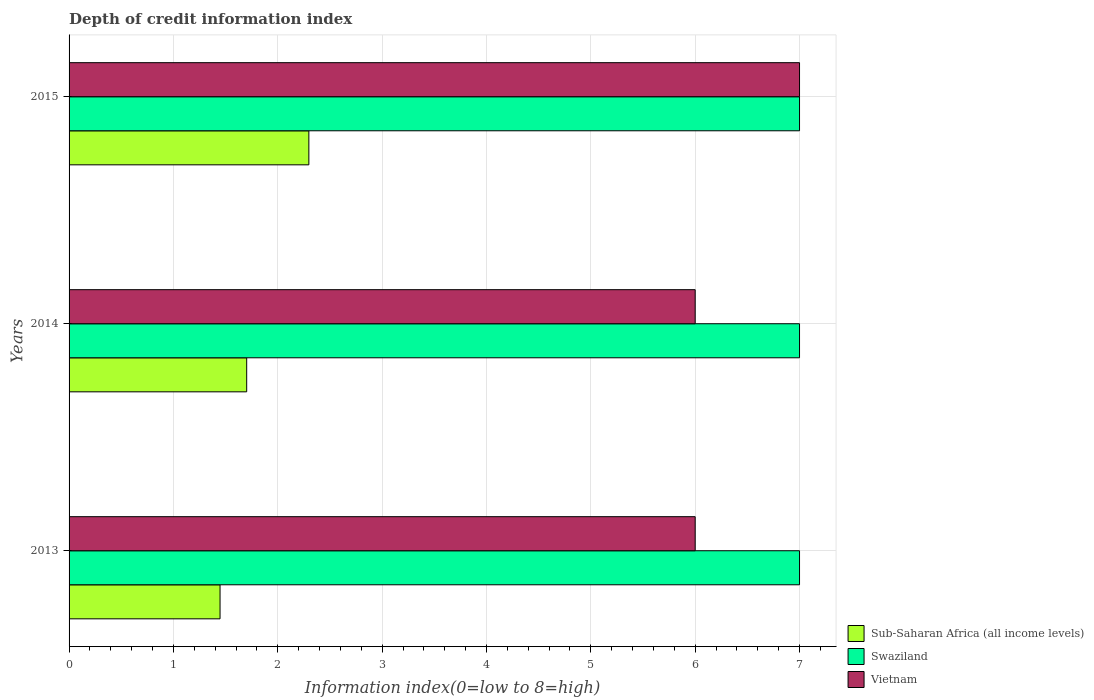How many bars are there on the 1st tick from the top?
Give a very brief answer. 3. How many bars are there on the 2nd tick from the bottom?
Your response must be concise. 3. What is the label of the 3rd group of bars from the top?
Your answer should be very brief. 2013. In how many cases, is the number of bars for a given year not equal to the number of legend labels?
Offer a very short reply. 0. What is the information index in Sub-Saharan Africa (all income levels) in 2013?
Make the answer very short. 1.45. Across all years, what is the maximum information index in Sub-Saharan Africa (all income levels)?
Offer a very short reply. 2.3. In which year was the information index in Swaziland maximum?
Provide a short and direct response. 2013. In which year was the information index in Sub-Saharan Africa (all income levels) minimum?
Provide a succinct answer. 2013. What is the total information index in Sub-Saharan Africa (all income levels) in the graph?
Give a very brief answer. 5.45. What is the difference between the information index in Sub-Saharan Africa (all income levels) in 2014 and that in 2015?
Offer a terse response. -0.6. What is the difference between the information index in Swaziland in 2013 and the information index in Vietnam in 2015?
Make the answer very short. 0. What is the average information index in Vietnam per year?
Your answer should be compact. 6.33. In the year 2014, what is the difference between the information index in Vietnam and information index in Sub-Saharan Africa (all income levels)?
Your answer should be compact. 4.3. In how many years, is the information index in Sub-Saharan Africa (all income levels) greater than 1 ?
Give a very brief answer. 3. What is the ratio of the information index in Swaziland in 2013 to that in 2015?
Provide a succinct answer. 1. Is the information index in Swaziland in 2013 less than that in 2015?
Make the answer very short. No. Is the difference between the information index in Vietnam in 2013 and 2014 greater than the difference between the information index in Sub-Saharan Africa (all income levels) in 2013 and 2014?
Offer a terse response. Yes. What is the difference between the highest and the second highest information index in Vietnam?
Ensure brevity in your answer.  1. What is the difference between the highest and the lowest information index in Sub-Saharan Africa (all income levels)?
Provide a short and direct response. 0.85. Is the sum of the information index in Sub-Saharan Africa (all income levels) in 2013 and 2014 greater than the maximum information index in Swaziland across all years?
Offer a terse response. No. What does the 3rd bar from the top in 2014 represents?
Offer a very short reply. Sub-Saharan Africa (all income levels). What does the 1st bar from the bottom in 2014 represents?
Give a very brief answer. Sub-Saharan Africa (all income levels). How many bars are there?
Your response must be concise. 9. How many years are there in the graph?
Provide a succinct answer. 3. Are the values on the major ticks of X-axis written in scientific E-notation?
Provide a short and direct response. No. Does the graph contain any zero values?
Give a very brief answer. No. Does the graph contain grids?
Provide a short and direct response. Yes. How many legend labels are there?
Offer a terse response. 3. How are the legend labels stacked?
Offer a very short reply. Vertical. What is the title of the graph?
Your answer should be very brief. Depth of credit information index. What is the label or title of the X-axis?
Keep it short and to the point. Information index(0=low to 8=high). What is the Information index(0=low to 8=high) in Sub-Saharan Africa (all income levels) in 2013?
Keep it short and to the point. 1.45. What is the Information index(0=low to 8=high) of Swaziland in 2013?
Provide a succinct answer. 7. What is the Information index(0=low to 8=high) of Sub-Saharan Africa (all income levels) in 2014?
Provide a short and direct response. 1.7. What is the Information index(0=low to 8=high) of Sub-Saharan Africa (all income levels) in 2015?
Provide a succinct answer. 2.3. What is the Information index(0=low to 8=high) of Swaziland in 2015?
Make the answer very short. 7. Across all years, what is the maximum Information index(0=low to 8=high) in Sub-Saharan Africa (all income levels)?
Make the answer very short. 2.3. Across all years, what is the maximum Information index(0=low to 8=high) of Swaziland?
Keep it short and to the point. 7. Across all years, what is the minimum Information index(0=low to 8=high) in Sub-Saharan Africa (all income levels)?
Give a very brief answer. 1.45. Across all years, what is the minimum Information index(0=low to 8=high) in Swaziland?
Offer a terse response. 7. What is the total Information index(0=low to 8=high) in Sub-Saharan Africa (all income levels) in the graph?
Your answer should be very brief. 5.45. What is the total Information index(0=low to 8=high) of Swaziland in the graph?
Ensure brevity in your answer.  21. What is the difference between the Information index(0=low to 8=high) in Sub-Saharan Africa (all income levels) in 2013 and that in 2014?
Keep it short and to the point. -0.26. What is the difference between the Information index(0=low to 8=high) in Swaziland in 2013 and that in 2014?
Provide a succinct answer. 0. What is the difference between the Information index(0=low to 8=high) of Vietnam in 2013 and that in 2014?
Provide a short and direct response. 0. What is the difference between the Information index(0=low to 8=high) of Sub-Saharan Africa (all income levels) in 2013 and that in 2015?
Provide a short and direct response. -0.85. What is the difference between the Information index(0=low to 8=high) in Sub-Saharan Africa (all income levels) in 2014 and that in 2015?
Give a very brief answer. -0.6. What is the difference between the Information index(0=low to 8=high) in Swaziland in 2014 and that in 2015?
Make the answer very short. 0. What is the difference between the Information index(0=low to 8=high) of Sub-Saharan Africa (all income levels) in 2013 and the Information index(0=low to 8=high) of Swaziland in 2014?
Keep it short and to the point. -5.55. What is the difference between the Information index(0=low to 8=high) in Sub-Saharan Africa (all income levels) in 2013 and the Information index(0=low to 8=high) in Vietnam in 2014?
Provide a succinct answer. -4.55. What is the difference between the Information index(0=low to 8=high) in Sub-Saharan Africa (all income levels) in 2013 and the Information index(0=low to 8=high) in Swaziland in 2015?
Ensure brevity in your answer.  -5.55. What is the difference between the Information index(0=low to 8=high) in Sub-Saharan Africa (all income levels) in 2013 and the Information index(0=low to 8=high) in Vietnam in 2015?
Ensure brevity in your answer.  -5.55. What is the difference between the Information index(0=low to 8=high) in Swaziland in 2013 and the Information index(0=low to 8=high) in Vietnam in 2015?
Offer a very short reply. 0. What is the difference between the Information index(0=low to 8=high) in Sub-Saharan Africa (all income levels) in 2014 and the Information index(0=low to 8=high) in Swaziland in 2015?
Your answer should be compact. -5.3. What is the difference between the Information index(0=low to 8=high) in Sub-Saharan Africa (all income levels) in 2014 and the Information index(0=low to 8=high) in Vietnam in 2015?
Ensure brevity in your answer.  -5.3. What is the average Information index(0=low to 8=high) of Sub-Saharan Africa (all income levels) per year?
Provide a succinct answer. 1.82. What is the average Information index(0=low to 8=high) of Vietnam per year?
Provide a succinct answer. 6.33. In the year 2013, what is the difference between the Information index(0=low to 8=high) in Sub-Saharan Africa (all income levels) and Information index(0=low to 8=high) in Swaziland?
Make the answer very short. -5.55. In the year 2013, what is the difference between the Information index(0=low to 8=high) of Sub-Saharan Africa (all income levels) and Information index(0=low to 8=high) of Vietnam?
Your answer should be very brief. -4.55. In the year 2014, what is the difference between the Information index(0=low to 8=high) of Sub-Saharan Africa (all income levels) and Information index(0=low to 8=high) of Swaziland?
Provide a succinct answer. -5.3. In the year 2014, what is the difference between the Information index(0=low to 8=high) in Sub-Saharan Africa (all income levels) and Information index(0=low to 8=high) in Vietnam?
Keep it short and to the point. -4.3. In the year 2014, what is the difference between the Information index(0=low to 8=high) in Swaziland and Information index(0=low to 8=high) in Vietnam?
Keep it short and to the point. 1. In the year 2015, what is the difference between the Information index(0=low to 8=high) in Sub-Saharan Africa (all income levels) and Information index(0=low to 8=high) in Swaziland?
Ensure brevity in your answer.  -4.7. In the year 2015, what is the difference between the Information index(0=low to 8=high) of Sub-Saharan Africa (all income levels) and Information index(0=low to 8=high) of Vietnam?
Keep it short and to the point. -4.7. What is the ratio of the Information index(0=low to 8=high) of Sub-Saharan Africa (all income levels) in 2013 to that in 2015?
Keep it short and to the point. 0.63. What is the ratio of the Information index(0=low to 8=high) in Vietnam in 2013 to that in 2015?
Your response must be concise. 0.86. What is the ratio of the Information index(0=low to 8=high) in Sub-Saharan Africa (all income levels) in 2014 to that in 2015?
Make the answer very short. 0.74. What is the difference between the highest and the second highest Information index(0=low to 8=high) in Sub-Saharan Africa (all income levels)?
Offer a terse response. 0.6. What is the difference between the highest and the second highest Information index(0=low to 8=high) of Vietnam?
Provide a short and direct response. 1. What is the difference between the highest and the lowest Information index(0=low to 8=high) in Sub-Saharan Africa (all income levels)?
Offer a very short reply. 0.85. What is the difference between the highest and the lowest Information index(0=low to 8=high) in Swaziland?
Provide a succinct answer. 0. What is the difference between the highest and the lowest Information index(0=low to 8=high) of Vietnam?
Your response must be concise. 1. 